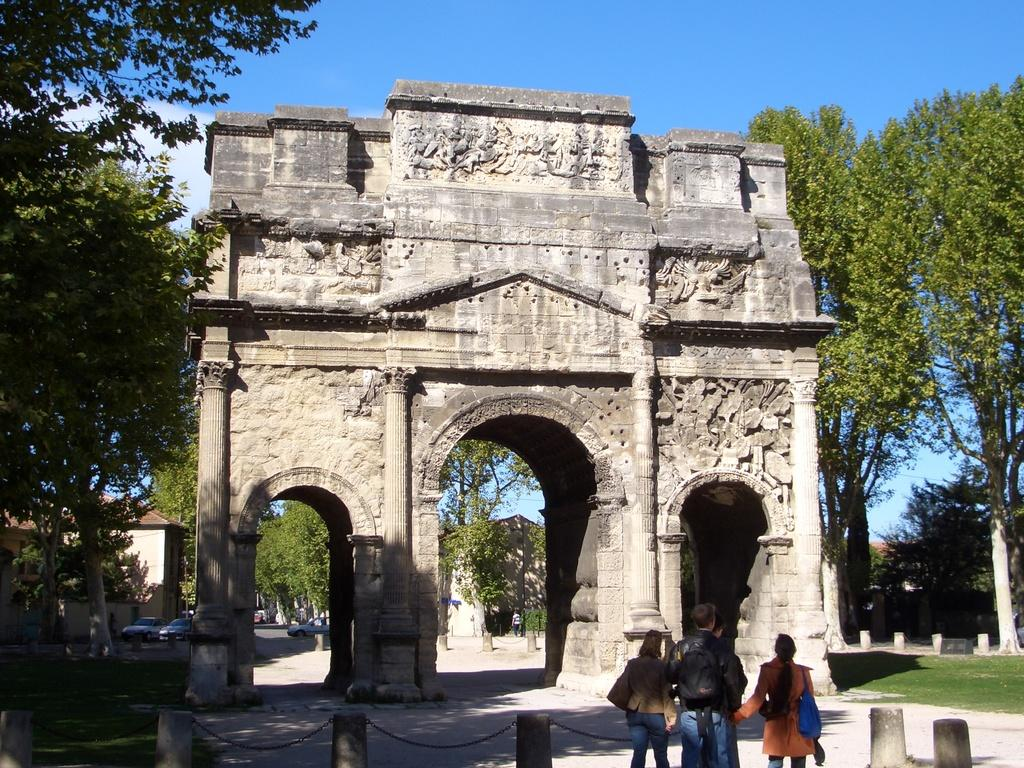What type of structure is in the image? There is an arch gate in the image. What is happening on the road in the image? Motor vehicles are present on the road in the image. What are the barrier poles used for in the image? Barrier poles are visible in the image, likely to control traffic or restrict access. What are the persons in the image doing? There are persons standing on the ground in the image. What type of man-made structures can be seen in the image? There are buildings in the image. What type of natural elements are present in the image? Trees are present in the image. What is visible in the sky in the image? The sky is visible in the image, and clouds are visible in the sky. What type of loaf is being used as a skate by the person sitting on the furniture in the image? There is no loaf, skate, or furniture present in the image. 